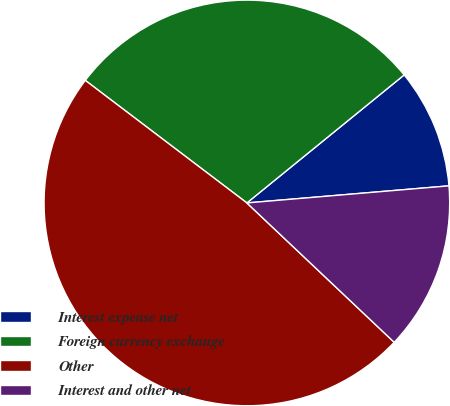<chart> <loc_0><loc_0><loc_500><loc_500><pie_chart><fcel>Interest expense net<fcel>Foreign currency exchange<fcel>Other<fcel>Interest and other net<nl><fcel>9.53%<fcel>28.8%<fcel>48.27%<fcel>13.4%<nl></chart> 